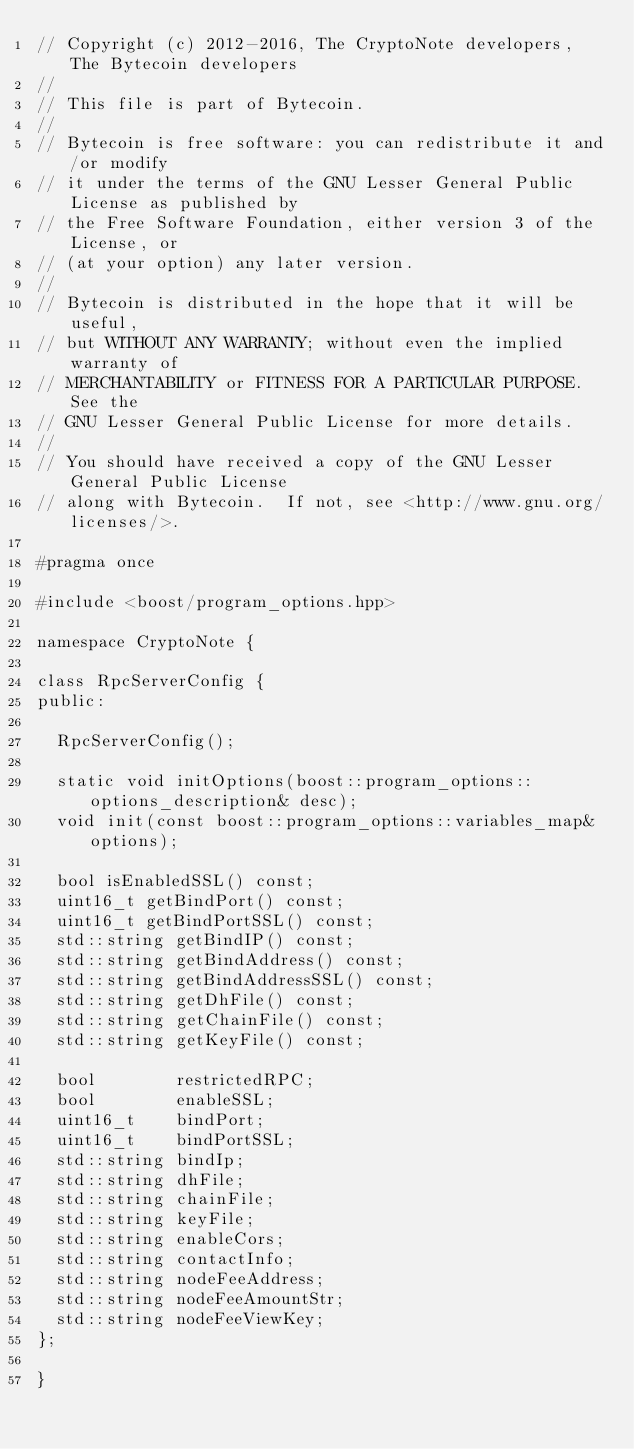<code> <loc_0><loc_0><loc_500><loc_500><_C_>// Copyright (c) 2012-2016, The CryptoNote developers, The Bytecoin developers
//
// This file is part of Bytecoin.
//
// Bytecoin is free software: you can redistribute it and/or modify
// it under the terms of the GNU Lesser General Public License as published by
// the Free Software Foundation, either version 3 of the License, or
// (at your option) any later version.
//
// Bytecoin is distributed in the hope that it will be useful,
// but WITHOUT ANY WARRANTY; without even the implied warranty of
// MERCHANTABILITY or FITNESS FOR A PARTICULAR PURPOSE.  See the
// GNU Lesser General Public License for more details.
//
// You should have received a copy of the GNU Lesser General Public License
// along with Bytecoin.  If not, see <http://www.gnu.org/licenses/>.

#pragma once

#include <boost/program_options.hpp>

namespace CryptoNote {

class RpcServerConfig {
public:

  RpcServerConfig();

  static void initOptions(boost::program_options::options_description& desc);
  void init(const boost::program_options::variables_map& options);

  bool isEnabledSSL() const;
  uint16_t getBindPort() const;
  uint16_t getBindPortSSL() const;
  std::string getBindIP() const;
  std::string getBindAddress() const;
  std::string getBindAddressSSL() const;
  std::string getDhFile() const;
  std::string getChainFile() const;
  std::string getKeyFile() const;

  bool        restrictedRPC;
  bool        enableSSL;
  uint16_t    bindPort;
  uint16_t    bindPortSSL;
  std::string bindIp;
  std::string dhFile;
  std::string chainFile;
  std::string keyFile;
  std::string enableCors;
  std::string contactInfo;
  std::string nodeFeeAddress;
  std::string nodeFeeAmountStr;
  std::string nodeFeeViewKey;
};

}
</code> 